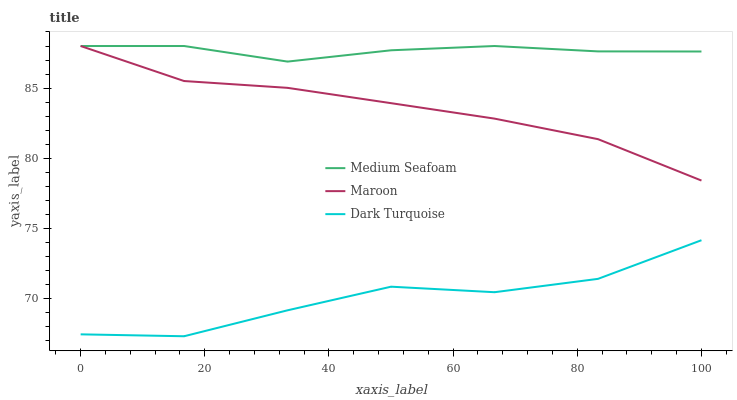Does Dark Turquoise have the minimum area under the curve?
Answer yes or no. Yes. Does Medium Seafoam have the maximum area under the curve?
Answer yes or no. Yes. Does Maroon have the minimum area under the curve?
Answer yes or no. No. Does Maroon have the maximum area under the curve?
Answer yes or no. No. Is Maroon the smoothest?
Answer yes or no. Yes. Is Dark Turquoise the roughest?
Answer yes or no. Yes. Is Medium Seafoam the smoothest?
Answer yes or no. No. Is Medium Seafoam the roughest?
Answer yes or no. No. Does Dark Turquoise have the lowest value?
Answer yes or no. Yes. Does Maroon have the lowest value?
Answer yes or no. No. Does Maroon have the highest value?
Answer yes or no. Yes. Is Dark Turquoise less than Maroon?
Answer yes or no. Yes. Is Maroon greater than Dark Turquoise?
Answer yes or no. Yes. Does Medium Seafoam intersect Maroon?
Answer yes or no. Yes. Is Medium Seafoam less than Maroon?
Answer yes or no. No. Is Medium Seafoam greater than Maroon?
Answer yes or no. No. Does Dark Turquoise intersect Maroon?
Answer yes or no. No. 